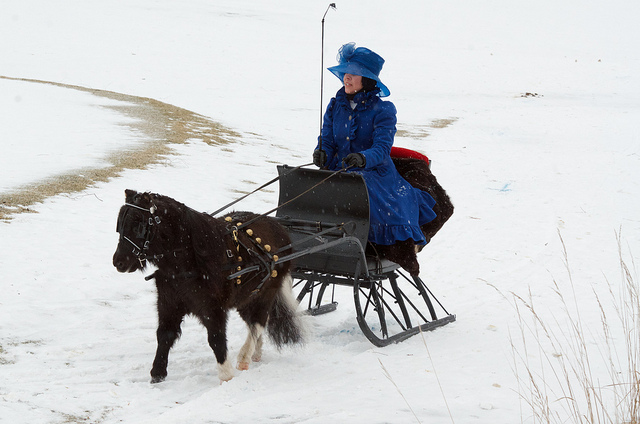Can you describe the weather conditions in the image? The weather looks quite cold and overcast, with a snowy ground indicating recent snowfall. It's likely that the temperature is near or below freezing. 